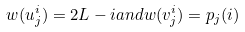<formula> <loc_0><loc_0><loc_500><loc_500>w ( u _ { j } ^ { i } ) = 2 L - i a n d w ( v _ { j } ^ { i } ) = p _ { j } ( i )</formula> 